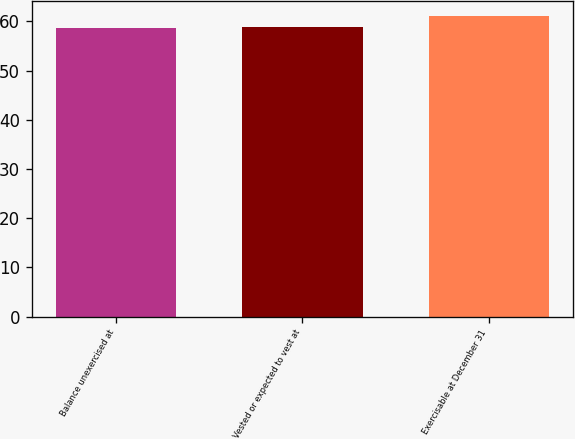<chart> <loc_0><loc_0><loc_500><loc_500><bar_chart><fcel>Balance unexercised at<fcel>Vested or expected to vest at<fcel>Exercisable at December 31<nl><fcel>58.66<fcel>58.9<fcel>61.05<nl></chart> 